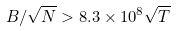Convert formula to latex. <formula><loc_0><loc_0><loc_500><loc_500>B / \sqrt { N } > 8 . 3 \times 1 0 ^ { 8 } \sqrt { T }</formula> 